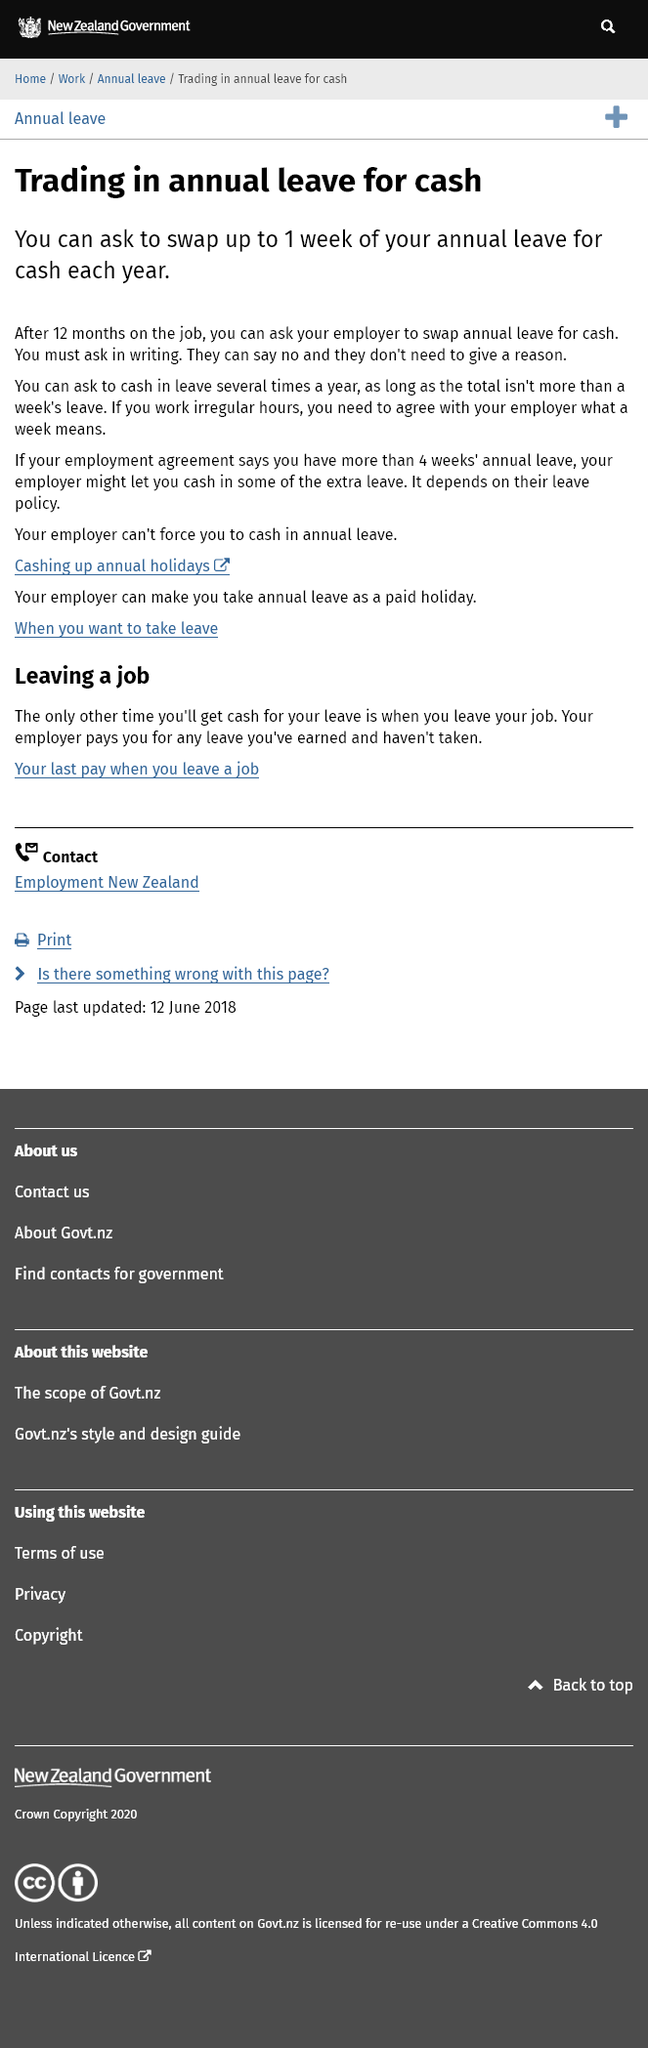Draw attention to some important aspects in this diagram. You can trade in annual leave for cash after 12 months of employment, as long as you have reached the eligibility requirements set by your employer. You cannot trade in more than a week of annual leave for cash. Employers are not required to trade annual leave for cash. 